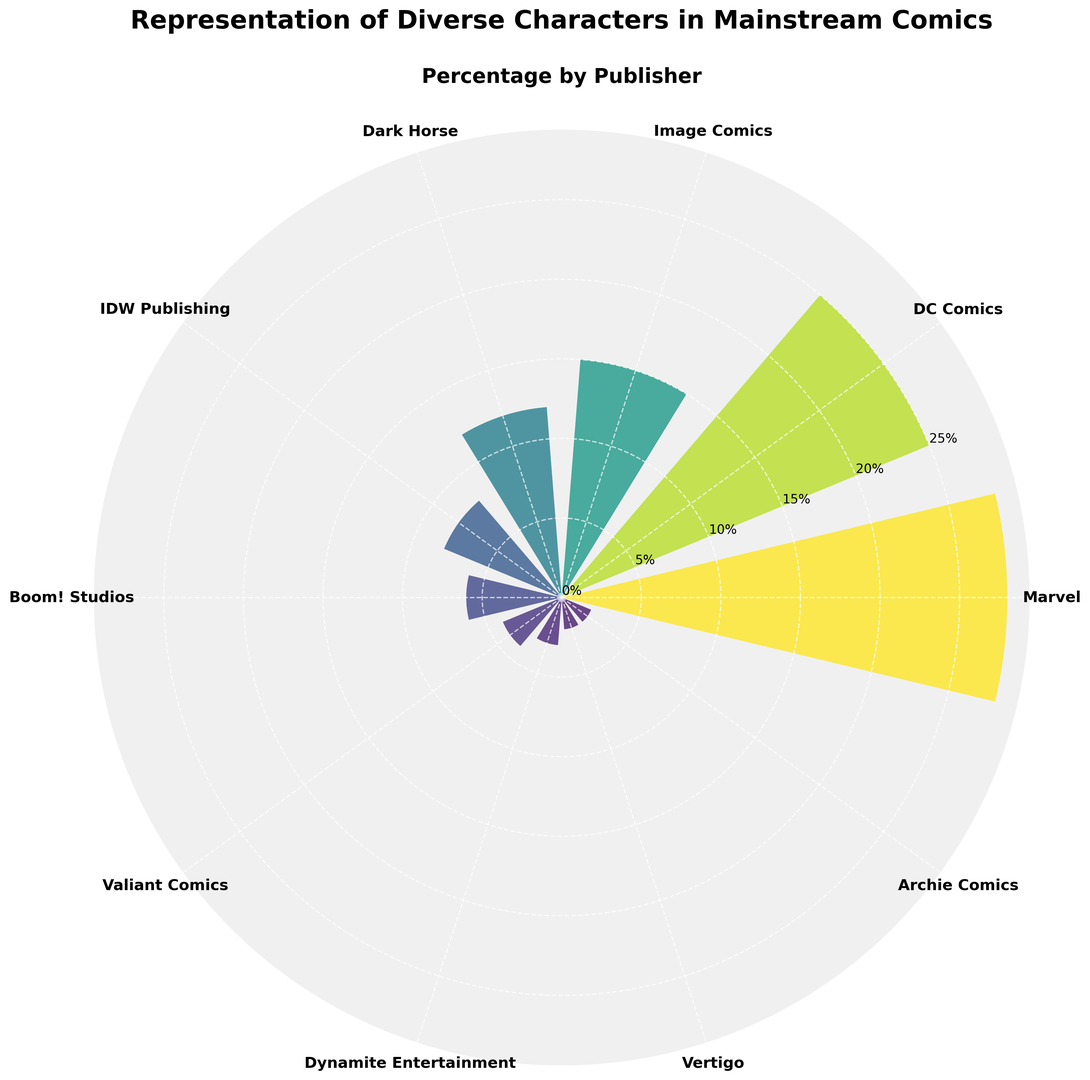Which publisher has the highest percentage of diverse character representation? Looking at the chart, the bar with the highest radii represents the publisher with the highest percentage of diverse character representation.
Answer: Marvel Which publisher has the lowest percentage of diverse character representation? The shortest bar on the chart indicates the publisher with the lowest percentage of diverse character representation.
Answer: Archie Comics / Vertigo What is the combined percentage representation of diverse characters for Marvel and DC Comics? To find this, add the percentages of Marvel and DC Comics shown in the chart: 28% (Marvel) + 25% (DC Comics).
Answer: 53% How does the representation of diverse characters in Image Comics compare to that in Dark Horse? By comparing the heights of the bars, Image Comics (15%) has a higher percentage of diverse characters than Dark Horse (12%).
Answer: Image Comics has a higher percentage What's the total percentage representation of diverse characters by IDW Publishing, Boom! Studios, and Valiant Comics? Sum the percentages of IDW Publishing (8%), Boom! Studios (6%), Valiant Comics (4%): 8% + 6% + 4%.
Answer: 18% Which publisher has a percentage closest to the average percentage representation among all publishers? First, calculate the average percentage: (28 + 25 + 15 + 12 + 8 + 6 + 4 + 3 + 2 + 2) / 10 = 10.5. Then see which publisher's percentage is closest to 10.5%.
Answer: Dark Horse (12%) What is the percentage difference between Marvel and Dynamite Entertainment? Subtract the percentage of Dynamite Entertainment from Marvel: 28% - 3%.
Answer: 25% Rank the top three publishers by percentage of diverse character representation. Look at the three bars with the highest percentages.
Answer: Marvel, DC Comics, Image Comics Which publisher with less than a 10% representation of diverse characters has the highest percentage? Among publishers with less than 10%, compare the bars' heights: IDW Publishing (8%), Boom! Studios (6%), Valiant Comics (4%), etc.
Answer: IDW Publishing 